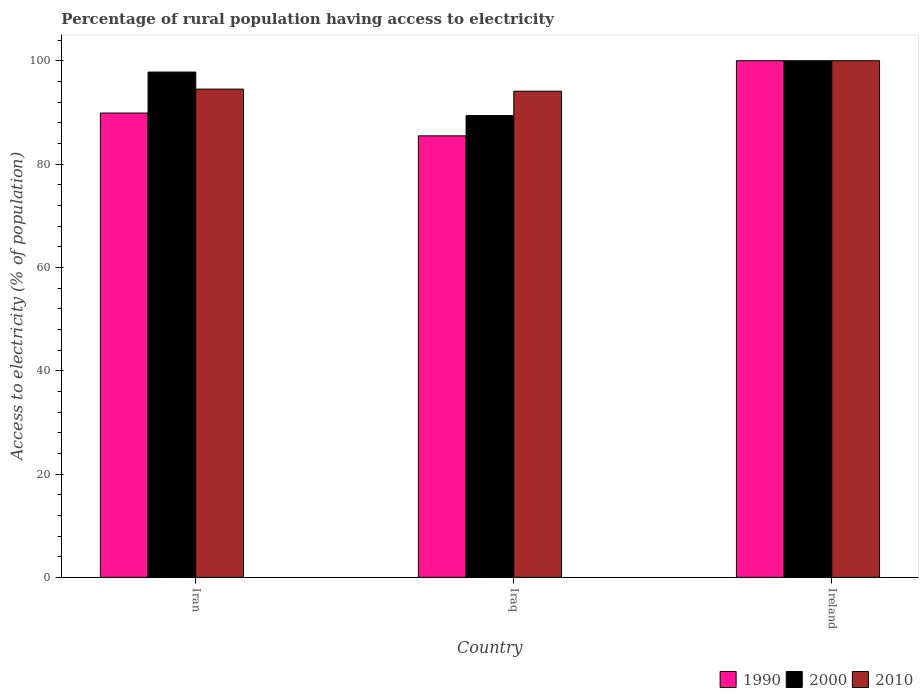How many different coloured bars are there?
Your response must be concise. 3. How many groups of bars are there?
Provide a succinct answer. 3. Are the number of bars per tick equal to the number of legend labels?
Your answer should be compact. Yes. What is the label of the 2nd group of bars from the left?
Offer a very short reply. Iraq. In how many cases, is the number of bars for a given country not equal to the number of legend labels?
Provide a short and direct response. 0. What is the percentage of rural population having access to electricity in 1990 in Iran?
Your response must be concise. 89.87. Across all countries, what is the maximum percentage of rural population having access to electricity in 2000?
Make the answer very short. 100. Across all countries, what is the minimum percentage of rural population having access to electricity in 1990?
Keep it short and to the point. 85.46. In which country was the percentage of rural population having access to electricity in 1990 maximum?
Your answer should be very brief. Ireland. In which country was the percentage of rural population having access to electricity in 2000 minimum?
Keep it short and to the point. Iraq. What is the total percentage of rural population having access to electricity in 2000 in the graph?
Give a very brief answer. 287.18. What is the difference between the percentage of rural population having access to electricity in 2010 in Iran and that in Iraq?
Offer a terse response. 0.4. What is the difference between the percentage of rural population having access to electricity in 1990 in Ireland and the percentage of rural population having access to electricity in 2000 in Iraq?
Offer a terse response. 10.62. What is the average percentage of rural population having access to electricity in 1990 per country?
Give a very brief answer. 91.78. What is the difference between the percentage of rural population having access to electricity of/in 2000 and percentage of rural population having access to electricity of/in 2010 in Ireland?
Give a very brief answer. 0. What is the ratio of the percentage of rural population having access to electricity in 1990 in Iran to that in Ireland?
Your answer should be compact. 0.9. What is the difference between the highest and the second highest percentage of rural population having access to electricity in 1990?
Offer a very short reply. -10.13. What is the difference between the highest and the lowest percentage of rural population having access to electricity in 1990?
Your answer should be compact. 14.54. In how many countries, is the percentage of rural population having access to electricity in 1990 greater than the average percentage of rural population having access to electricity in 1990 taken over all countries?
Offer a very short reply. 1. Is it the case that in every country, the sum of the percentage of rural population having access to electricity in 1990 and percentage of rural population having access to electricity in 2000 is greater than the percentage of rural population having access to electricity in 2010?
Offer a very short reply. Yes. Are the values on the major ticks of Y-axis written in scientific E-notation?
Provide a short and direct response. No. Does the graph contain grids?
Keep it short and to the point. No. Where does the legend appear in the graph?
Ensure brevity in your answer.  Bottom right. How many legend labels are there?
Make the answer very short. 3. What is the title of the graph?
Make the answer very short. Percentage of rural population having access to electricity. What is the label or title of the Y-axis?
Keep it short and to the point. Access to electricity (% of population). What is the Access to electricity (% of population) of 1990 in Iran?
Ensure brevity in your answer.  89.87. What is the Access to electricity (% of population) of 2000 in Iran?
Make the answer very short. 97.8. What is the Access to electricity (% of population) of 2010 in Iran?
Your response must be concise. 94.5. What is the Access to electricity (% of population) in 1990 in Iraq?
Your answer should be compact. 85.46. What is the Access to electricity (% of population) of 2000 in Iraq?
Keep it short and to the point. 89.38. What is the Access to electricity (% of population) of 2010 in Iraq?
Provide a short and direct response. 94.1. What is the Access to electricity (% of population) of 1990 in Ireland?
Keep it short and to the point. 100. What is the Access to electricity (% of population) of 2000 in Ireland?
Your answer should be compact. 100. What is the Access to electricity (% of population) in 2010 in Ireland?
Make the answer very short. 100. Across all countries, what is the maximum Access to electricity (% of population) in 2000?
Your answer should be compact. 100. Across all countries, what is the minimum Access to electricity (% of population) in 1990?
Offer a terse response. 85.46. Across all countries, what is the minimum Access to electricity (% of population) of 2000?
Offer a terse response. 89.38. Across all countries, what is the minimum Access to electricity (% of population) in 2010?
Keep it short and to the point. 94.1. What is the total Access to electricity (% of population) in 1990 in the graph?
Provide a succinct answer. 275.33. What is the total Access to electricity (% of population) in 2000 in the graph?
Keep it short and to the point. 287.18. What is the total Access to electricity (% of population) in 2010 in the graph?
Provide a short and direct response. 288.6. What is the difference between the Access to electricity (% of population) of 1990 in Iran and that in Iraq?
Give a very brief answer. 4.41. What is the difference between the Access to electricity (% of population) of 2000 in Iran and that in Iraq?
Provide a succinct answer. 8.42. What is the difference between the Access to electricity (% of population) in 1990 in Iran and that in Ireland?
Provide a succinct answer. -10.13. What is the difference between the Access to electricity (% of population) of 1990 in Iraq and that in Ireland?
Your answer should be compact. -14.54. What is the difference between the Access to electricity (% of population) of 2000 in Iraq and that in Ireland?
Provide a succinct answer. -10.62. What is the difference between the Access to electricity (% of population) in 1990 in Iran and the Access to electricity (% of population) in 2000 in Iraq?
Keep it short and to the point. 0.49. What is the difference between the Access to electricity (% of population) of 1990 in Iran and the Access to electricity (% of population) of 2010 in Iraq?
Your answer should be very brief. -4.23. What is the difference between the Access to electricity (% of population) of 2000 in Iran and the Access to electricity (% of population) of 2010 in Iraq?
Offer a very short reply. 3.7. What is the difference between the Access to electricity (% of population) of 1990 in Iran and the Access to electricity (% of population) of 2000 in Ireland?
Ensure brevity in your answer.  -10.13. What is the difference between the Access to electricity (% of population) in 1990 in Iran and the Access to electricity (% of population) in 2010 in Ireland?
Make the answer very short. -10.13. What is the difference between the Access to electricity (% of population) of 2000 in Iran and the Access to electricity (% of population) of 2010 in Ireland?
Your response must be concise. -2.2. What is the difference between the Access to electricity (% of population) in 1990 in Iraq and the Access to electricity (% of population) in 2000 in Ireland?
Your answer should be very brief. -14.54. What is the difference between the Access to electricity (% of population) of 1990 in Iraq and the Access to electricity (% of population) of 2010 in Ireland?
Your response must be concise. -14.54. What is the difference between the Access to electricity (% of population) of 2000 in Iraq and the Access to electricity (% of population) of 2010 in Ireland?
Offer a very short reply. -10.62. What is the average Access to electricity (% of population) of 1990 per country?
Ensure brevity in your answer.  91.78. What is the average Access to electricity (% of population) in 2000 per country?
Make the answer very short. 95.73. What is the average Access to electricity (% of population) of 2010 per country?
Offer a very short reply. 96.2. What is the difference between the Access to electricity (% of population) of 1990 and Access to electricity (% of population) of 2000 in Iran?
Offer a terse response. -7.93. What is the difference between the Access to electricity (% of population) in 1990 and Access to electricity (% of population) in 2010 in Iran?
Offer a very short reply. -4.63. What is the difference between the Access to electricity (% of population) in 1990 and Access to electricity (% of population) in 2000 in Iraq?
Provide a short and direct response. -3.92. What is the difference between the Access to electricity (% of population) in 1990 and Access to electricity (% of population) in 2010 in Iraq?
Make the answer very short. -8.64. What is the difference between the Access to electricity (% of population) of 2000 and Access to electricity (% of population) of 2010 in Iraq?
Your answer should be very brief. -4.72. What is the difference between the Access to electricity (% of population) in 1990 and Access to electricity (% of population) in 2010 in Ireland?
Your response must be concise. 0. What is the ratio of the Access to electricity (% of population) of 1990 in Iran to that in Iraq?
Offer a very short reply. 1.05. What is the ratio of the Access to electricity (% of population) of 2000 in Iran to that in Iraq?
Your answer should be compact. 1.09. What is the ratio of the Access to electricity (% of population) of 2010 in Iran to that in Iraq?
Provide a short and direct response. 1. What is the ratio of the Access to electricity (% of population) of 1990 in Iran to that in Ireland?
Ensure brevity in your answer.  0.9. What is the ratio of the Access to electricity (% of population) in 2000 in Iran to that in Ireland?
Provide a short and direct response. 0.98. What is the ratio of the Access to electricity (% of population) in 2010 in Iran to that in Ireland?
Offer a very short reply. 0.94. What is the ratio of the Access to electricity (% of population) of 1990 in Iraq to that in Ireland?
Offer a very short reply. 0.85. What is the ratio of the Access to electricity (% of population) of 2000 in Iraq to that in Ireland?
Provide a short and direct response. 0.89. What is the ratio of the Access to electricity (% of population) of 2010 in Iraq to that in Ireland?
Your response must be concise. 0.94. What is the difference between the highest and the second highest Access to electricity (% of population) in 1990?
Provide a succinct answer. 10.13. What is the difference between the highest and the second highest Access to electricity (% of population) of 2010?
Your answer should be very brief. 5.5. What is the difference between the highest and the lowest Access to electricity (% of population) in 1990?
Your response must be concise. 14.54. What is the difference between the highest and the lowest Access to electricity (% of population) of 2000?
Your answer should be very brief. 10.62. 